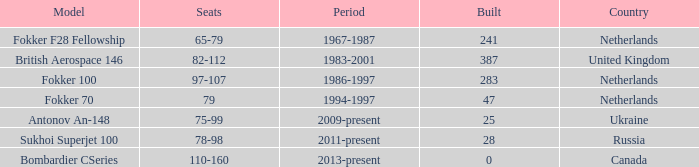In which years were 241 fokker 70 model cabins constructed? 1994-1997. 